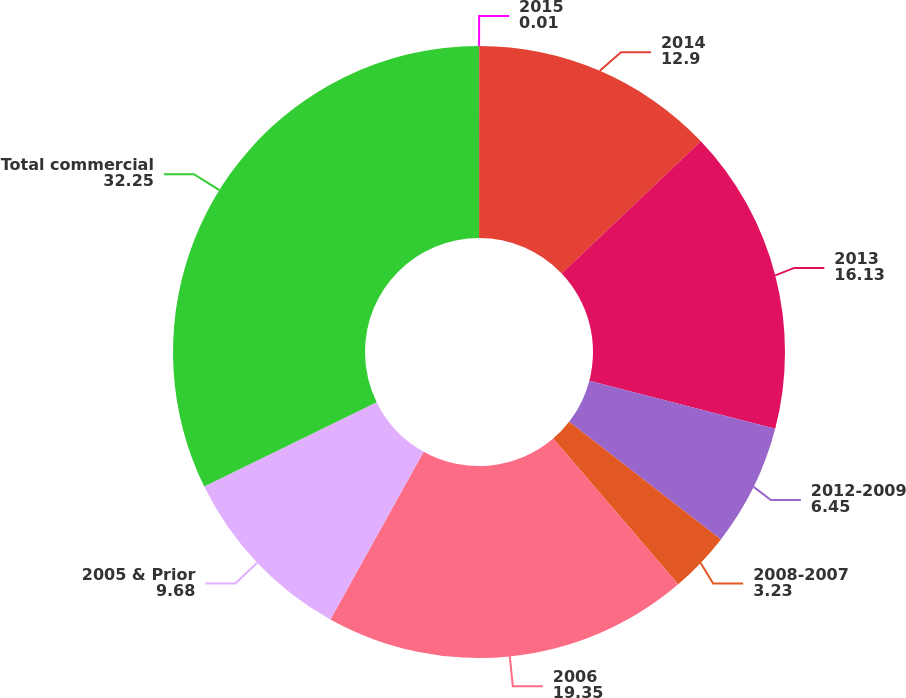Convert chart. <chart><loc_0><loc_0><loc_500><loc_500><pie_chart><fcel>2015<fcel>2014<fcel>2013<fcel>2012-2009<fcel>2008-2007<fcel>2006<fcel>2005 & Prior<fcel>Total commercial<nl><fcel>0.01%<fcel>12.9%<fcel>16.13%<fcel>6.45%<fcel>3.23%<fcel>19.35%<fcel>9.68%<fcel>32.25%<nl></chart> 